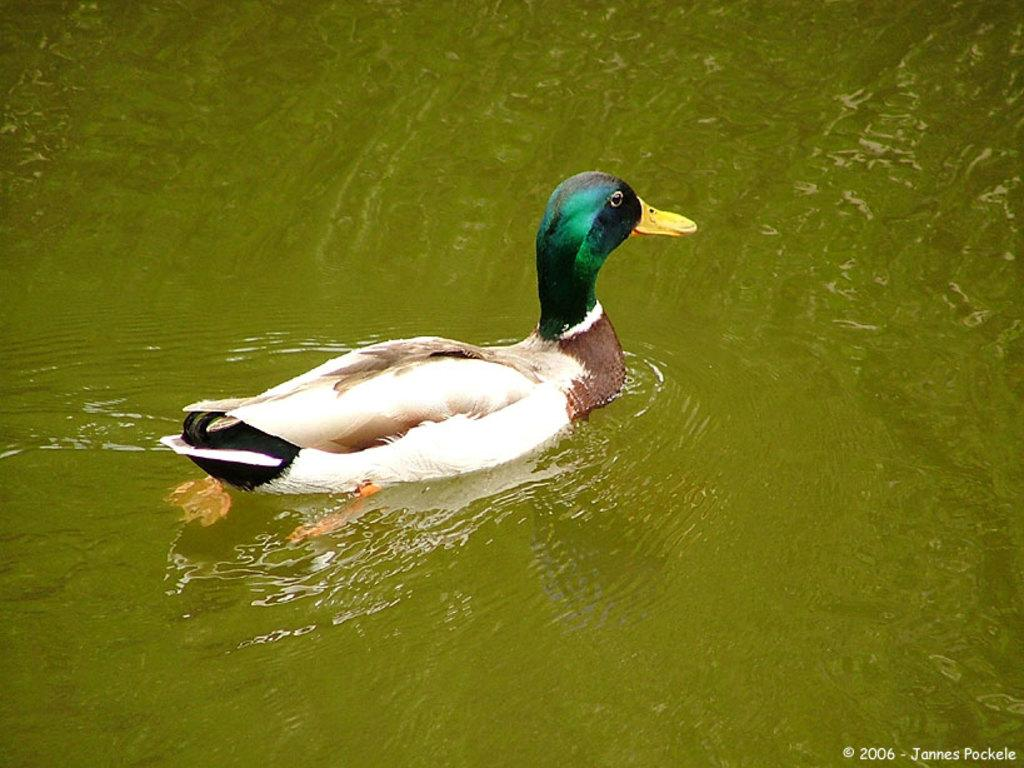What animal is present in the image? There is a duck in the image. Where is the duck located? The duck is in the water. Is the duck stuck in quicksand in the image? No, there is no quicksand present in the image, and the duck is in the water. What type of power source is used to operate the duck in the image? There is: There is no indication that the duck is operated by any power source in the image. 